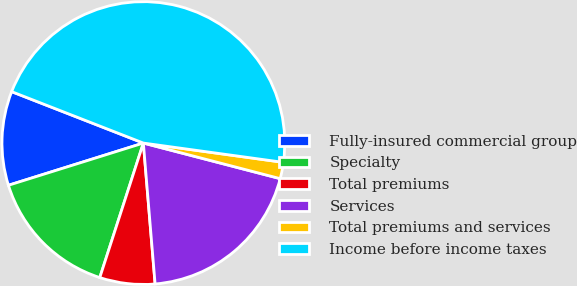Convert chart to OTSL. <chart><loc_0><loc_0><loc_500><loc_500><pie_chart><fcel>Fully-insured commercial group<fcel>Specialty<fcel>Total premiums<fcel>Services<fcel>Total premiums and services<fcel>Income before income taxes<nl><fcel>10.75%<fcel>15.19%<fcel>6.31%<fcel>19.63%<fcel>1.87%<fcel>46.26%<nl></chart> 